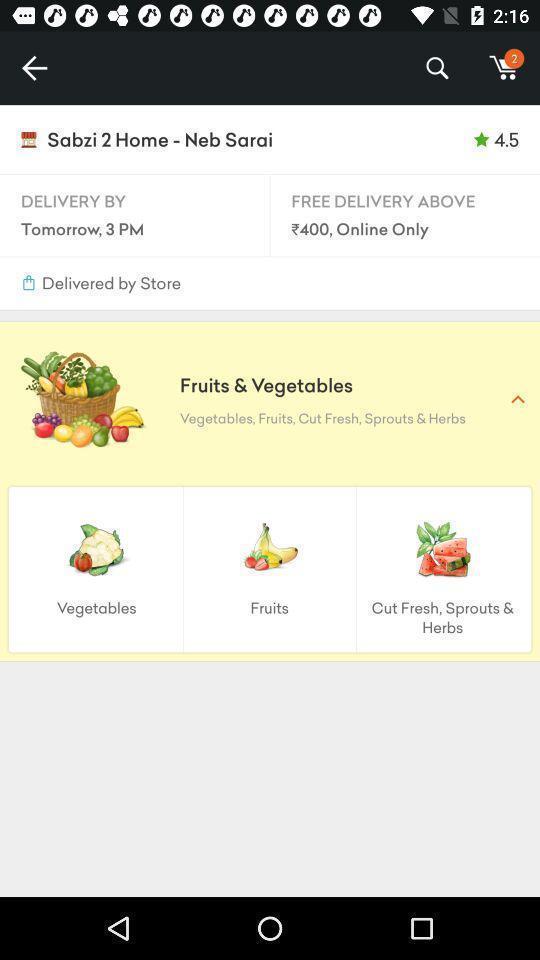Summarize the information in this screenshot. Page displaying to order fruits and veggies in application. 